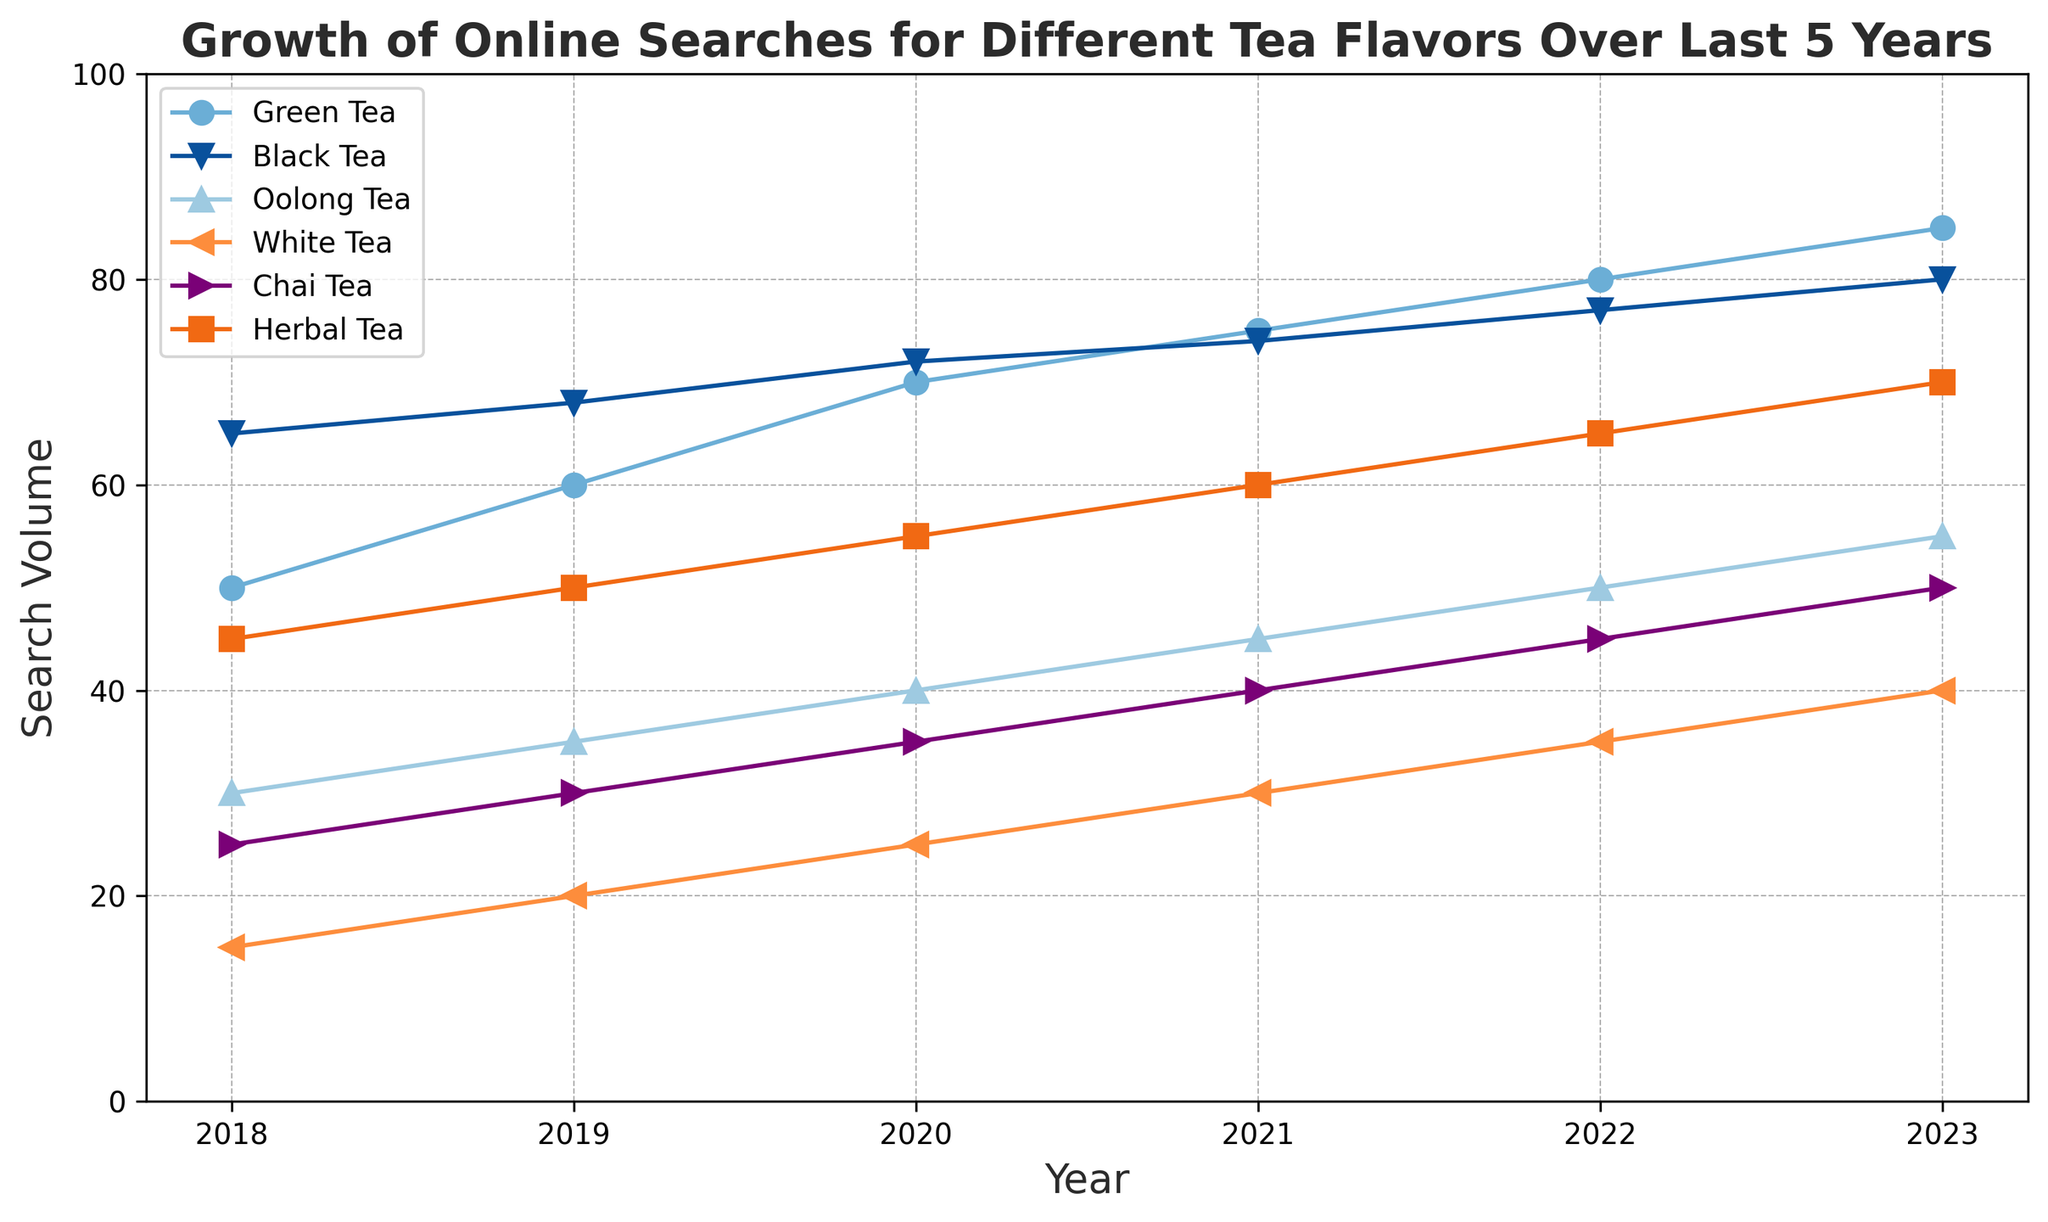what trend can be observed in the search volume for green tea from 2018 to 2023? By analyzing the line chart, the search volume for green tea exhibits a consistent upward trend over the period from 2018 (50) to 2023 (85).
Answer: Upward trend which tea flavor had the highest search volume in 2020? Looking at the data points in 2020, black tea has the highest search volume (72) compared to other tea flavors.
Answer: Black tea how did the search volumes for oolong tea and white tea change from 2018 to 2023? To determine the change, we subtract the 2018 values from the 2023 values: For oolong tea, it's 55 - 30 = 25, and for white tea, it's 40 - 15 = 25. Both tea types saw an increase of 25 in their search volumes.
Answer: Both increased by 25 compare the search volumes for chai tea and herbal tea in 2023. Which one was higher? In 2023, the search volume for chai tea was 50, whereas for herbal tea, it was 70. Herbal tea had a higher search volume.
Answer: Herbal tea what is the average search volume for black tea over the six years presented? The figures for black tea over six years are: 65, 68, 72, 74, 77, 80. Summing these gives 436, and dividing by 6 gives an average of 72.67.
Answer: 72.67 which tea flavor had the smallest increase in search volume between 2018 and 2023? By calculating the increase for each flavor: green tea (35), black tea (15), oolong tea (25), white tea (25), chai tea (25), herbal tea (25), black tea showed the smallest increase.
Answer: Black tea in which year did white tea see the largest increase in search volume compared to the previous year? By analyzing yearly changes: 2018-2019 (5), 2019-2020 (5), 2020-2021 (5), 2021-2022 (5), 2022-2023 (5), the increase each year is consistently 5, thus any year can be considered for the maximum increase.
Answer: Any year how much did the search volume for chai tea grow from 2020 to 2023? To find the growth, subtract the 2020 search volume from the 2023 volume: 50 - 35 = 15.
Answer: 15 which two tea flavors had exactly the same search volume in any year? Analyzing the graph, oolong tea (2021) and white tea (2023) both have a search volume of 55 in those respective years.
Answer: Oolong tea (2021) and White tea (2023) what can you say about the search volume patterns for herbal tea and oolong tea from 2018 to 2023? Both flavors show a consistent upward trend in search volumes, increasing yearly without any declines.
Answer: Consistent upward trend 